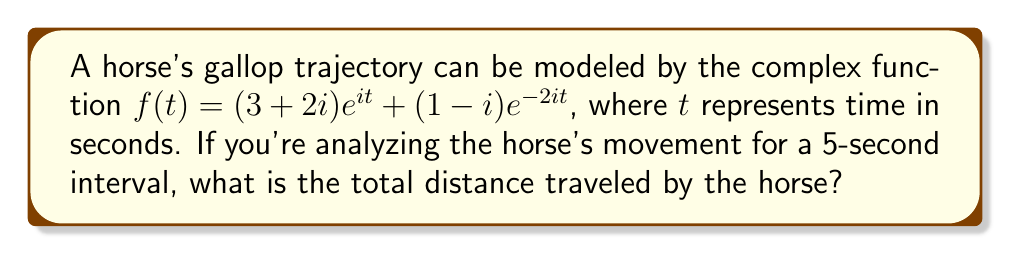What is the answer to this math problem? To find the total distance traveled, we need to calculate the arc length of the curve described by the complex function over the given time interval. Let's approach this step-by-step:

1) The arc length formula for a complex function $f(t)$ over an interval $[a,b]$ is:

   $$L = \int_a^b |f'(t)| dt$$

2) First, we need to find $f'(t)$:
   
   $$f'(t) = i(3+2i)e^{it} - 2i(1-i)e^{-2it}$$

3) Now, we need to calculate $|f'(t)|$:
   
   $$|f'(t)| = \sqrt{(i(3+2i)e^{it} - 2i(1-i)e^{-2it}) \cdot \overline{(i(3+2i)e^{it} - 2i(1-i)e^{-2it})}$$

4) Expanding this:
   
   $$|f'(t)| = \sqrt{13 + 10\cos(3t) + 6\sin(3t)}$$

5) Now, we need to integrate this from 0 to 5:

   $$L = \int_0^5 \sqrt{13 + 10\cos(3t) + 6\sin(3t)} dt$$

6) This integral doesn't have an elementary antiderivative, so we need to use numerical integration methods. Using a computational tool or calculator with numerical integration capabilities, we find:

   $$L \approx 18.76$$

Therefore, the total distance traveled by the horse over the 5-second interval is approximately 18.76 units.
Answer: $18.76$ units 